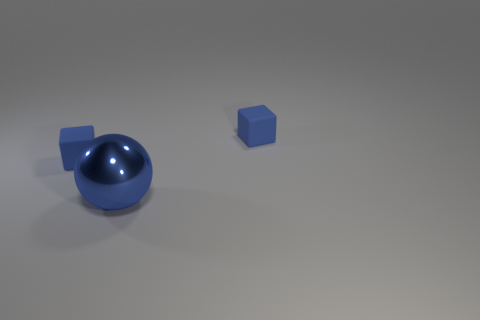Subtract 2 cubes. How many cubes are left? 0 Subtract all yellow blocks. How many gray spheres are left? 0 Subtract all large blue metal balls. Subtract all metallic blocks. How many objects are left? 2 Add 2 large blue objects. How many large blue objects are left? 3 Add 1 cubes. How many cubes exist? 3 Add 3 big yellow rubber cubes. How many objects exist? 6 Subtract 0 yellow cubes. How many objects are left? 3 Subtract all cubes. How many objects are left? 1 Subtract all green blocks. Subtract all yellow balls. How many blocks are left? 2 